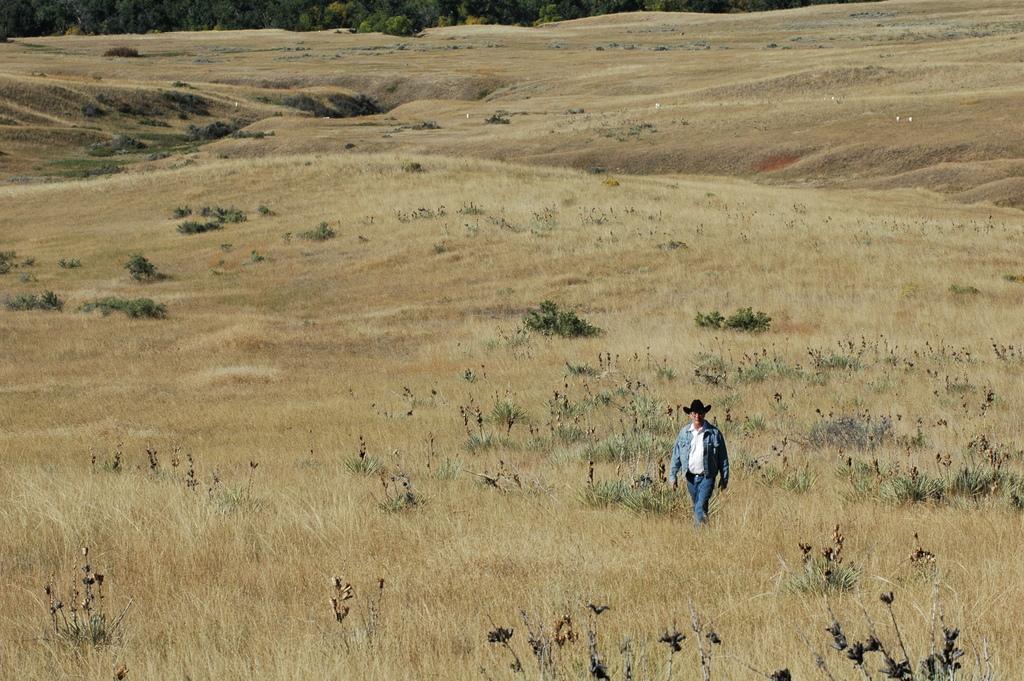How would you summarize this image in a sentence or two? In the center of the image we can see a man is walking on the ground and wearing a jacket, jeans, hat. In the background of the image we can see the grass and plants. At the top of the image we can see the trees. 